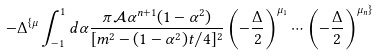Convert formula to latex. <formula><loc_0><loc_0><loc_500><loc_500>- \Delta ^ { \{ \mu } \int _ { - 1 } ^ { 1 } d \alpha \frac { \pi \mathcal { A } \alpha ^ { n + 1 } ( 1 - \alpha ^ { 2 } ) } { [ m ^ { 2 } - ( 1 - \alpha ^ { 2 } ) t / 4 ] ^ { 2 } } \left ( - \frac { \Delta } { 2 } \right ) ^ { \mu _ { 1 } } \cdots \left ( - \frac { \Delta } { 2 } \right ) ^ { \mu _ { n } \} }</formula> 